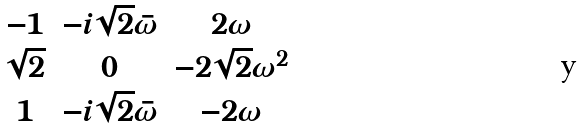Convert formula to latex. <formula><loc_0><loc_0><loc_500><loc_500>\begin{matrix} - 1 & - i \sqrt { 2 } \bar { \omega } & 2 \omega \\ \sqrt { 2 } & 0 & - 2 \sqrt { 2 } \omega ^ { 2 } \\ 1 & - i \sqrt { 2 } \bar { \omega } & - 2 \omega \end{matrix}</formula> 